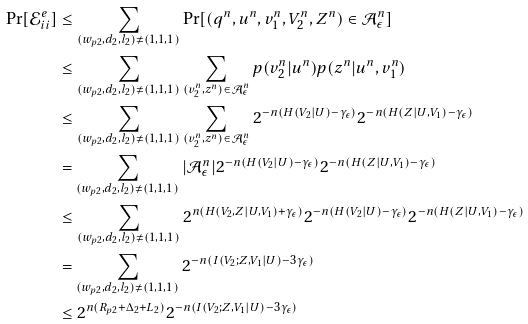Convert formula to latex. <formula><loc_0><loc_0><loc_500><loc_500>\Pr [ \mathcal { E } _ { i i } ^ { e } ] & \leq \sum _ { ( w _ { p 2 } , d _ { 2 } , l _ { 2 } ) \neq ( 1 , 1 , 1 ) } \Pr [ ( q ^ { n } , u ^ { n } , v _ { 1 } ^ { n } , V _ { 2 } ^ { n } , Z ^ { n } ) \in \mathcal { A } _ { \epsilon } ^ { n } ] \\ & \leq \sum _ { ( w _ { p 2 } , d _ { 2 } , l _ { 2 } ) \neq ( 1 , 1 , 1 ) } \sum _ { ( v _ { 2 } ^ { n } , z ^ { n } ) \in \mathcal { A } _ { \epsilon } ^ { n } } p ( v _ { 2 } ^ { n } | u ^ { n } ) p ( z ^ { n } | u ^ { n } , v _ { 1 } ^ { n } ) \\ & \leq \sum _ { ( w _ { p 2 } , d _ { 2 } , l _ { 2 } ) \neq ( 1 , 1 , 1 ) } \sum _ { ( v _ { 2 } ^ { n } , z ^ { n } ) \in \mathcal { A } _ { \epsilon } ^ { n } } 2 ^ { - n ( H ( V _ { 2 } | U ) - \gamma _ { \epsilon } ) } 2 ^ { - n ( H ( Z | U , V _ { 1 } ) - \gamma _ { \epsilon } ) } \\ & = \sum _ { ( w _ { p 2 } , d _ { 2 } , l _ { 2 } ) \neq ( 1 , 1 , 1 ) } | \mathcal { A } _ { \epsilon } ^ { n } | 2 ^ { - n ( H ( V _ { 2 } | U ) - \gamma _ { \epsilon } ) } 2 ^ { - n ( H ( Z | U , V _ { 1 } ) - \gamma _ { \epsilon } ) } \\ & \leq \sum _ { ( w _ { p 2 } , d _ { 2 } , l _ { 2 } ) \neq ( 1 , 1 , 1 ) } 2 ^ { n ( H ( V _ { 2 } , Z | U , V _ { 1 } ) + \gamma _ { \epsilon } ) } 2 ^ { - n ( H ( V _ { 2 } | U ) - \gamma _ { \epsilon } ) } 2 ^ { - n ( H ( Z | U , V _ { 1 } ) - \gamma _ { \epsilon } ) } \\ & = \sum _ { ( w _ { p 2 } , d _ { 2 } , l _ { 2 } ) \neq ( 1 , 1 , 1 ) } 2 ^ { - n ( I ( V _ { 2 } ; Z , V _ { 1 } | U ) - 3 \gamma _ { \epsilon } ) } \\ & \leq 2 ^ { n ( R _ { p 2 } + \Delta _ { 2 } + L _ { 2 } ) } 2 ^ { - n ( I ( V _ { 2 } ; Z , V _ { 1 } | U ) - 3 \gamma _ { \epsilon } ) }</formula> 